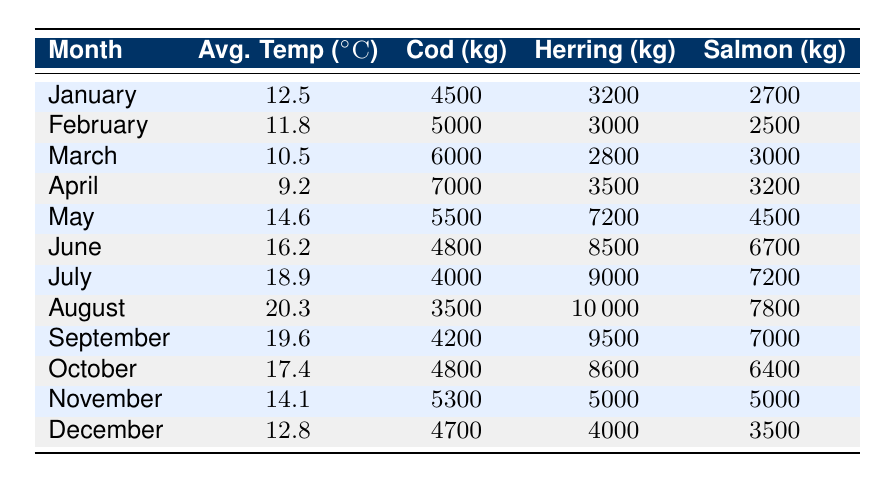What is the average ocean temperature in June? Referring to the table, the average ocean temperature for June is listed directly.
Answer: 16.2 Which month had the highest fish catch quantity for Herring? By examining the table, August has the highest quantity of Herring caught at 10,000 kg compared to other months.
Answer: August What is the total fish catch quantity for Cod in the first quarter (January to March)? To find the total fish catch quantity for Cod in the first quarter, sum the quantities in January (4500 kg), February (5000 kg), and March (6000 kg), which equals 4500 + 5000 + 6000 = 15500 kg.
Answer: 15500 Did the fish catch quantity for Salmon increase from April to May? In April, the fish catch for Salmon was 3200 kg, while in May, it was 4500 kg, indicating an increase.
Answer: Yes What is the difference in average ocean temperature between the warmest and coldest months? The warmest month is August with 20.3 °C and the coldest is April with 9.2 °C. The difference is 20.3 - 9.2 = 11.1 °C.
Answer: 11.1 In which month did Cod have the lowest catch quantity? Scanning the table for Cod, July shows the lowest catch quantity of 4000 kg compared to other months.
Answer: July What is the average fish catch quantity of Herring from January to March? The quantities of Herring for January (3200 kg), February (3000 kg), and March (2800 kg) should be averaged. The sum is 3200 + 3000 + 2800 = 9000 kg, and divided by 3 gives an average of 9000 / 3 = 3000 kg.
Answer: 3000 Which month had a fish catch quantity for Salmon above 6000 kg? Upon reviewing the table, both June (6700 kg) and July (7200 kg) have quantities above 6000 kg for Salmon.
Answer: June and July Was the average ocean temperature higher in November or December? Comparing the values, November has an average ocean temperature of 14.1 °C and December has 12.8 °C; thus, November is higher.
Answer: November 